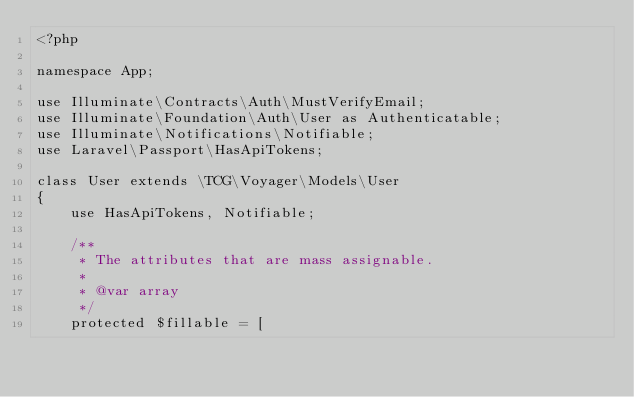Convert code to text. <code><loc_0><loc_0><loc_500><loc_500><_PHP_><?php

namespace App;

use Illuminate\Contracts\Auth\MustVerifyEmail;
use Illuminate\Foundation\Auth\User as Authenticatable;
use Illuminate\Notifications\Notifiable;
use Laravel\Passport\HasApiTokens;

class User extends \TCG\Voyager\Models\User
{
    use HasApiTokens, Notifiable;

    /**
     * The attributes that are mass assignable.
     *
     * @var array
     */
    protected $fillable = [</code> 